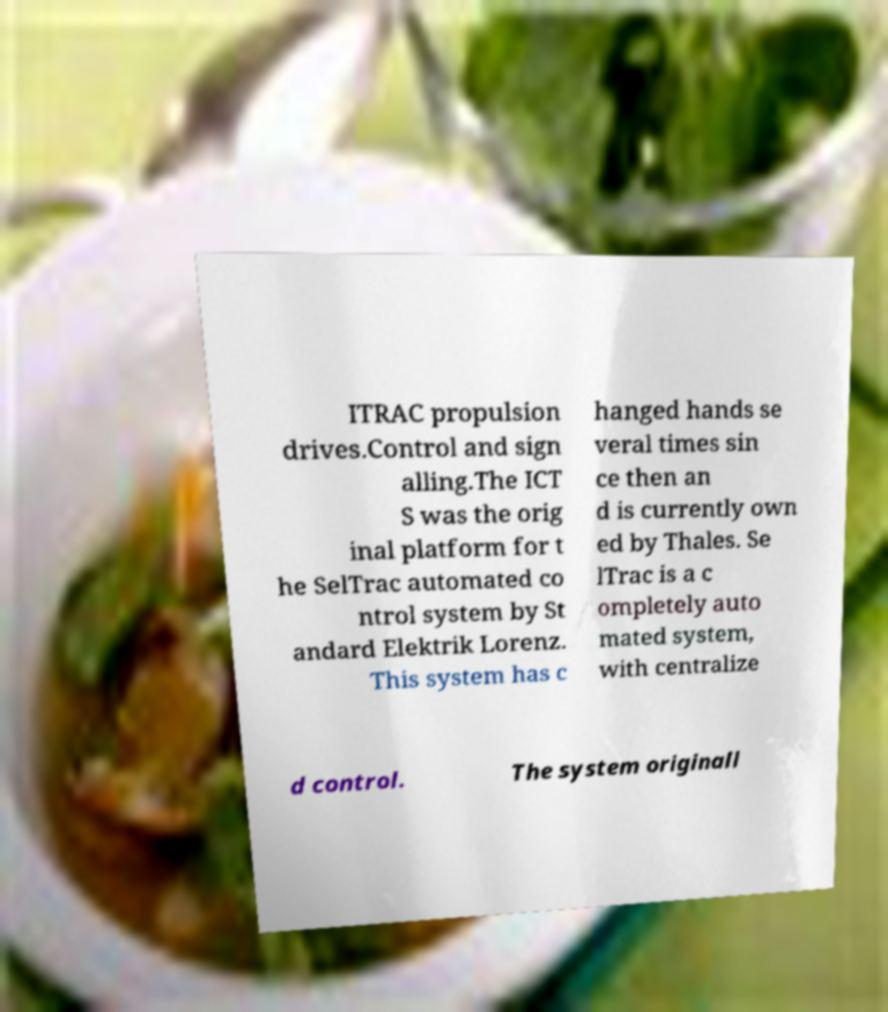What messages or text are displayed in this image? I need them in a readable, typed format. ITRAC propulsion drives.Control and sign alling.The ICT S was the orig inal platform for t he SelTrac automated co ntrol system by St andard Elektrik Lorenz. This system has c hanged hands se veral times sin ce then an d is currently own ed by Thales. Se lTrac is a c ompletely auto mated system, with centralize d control. The system originall 